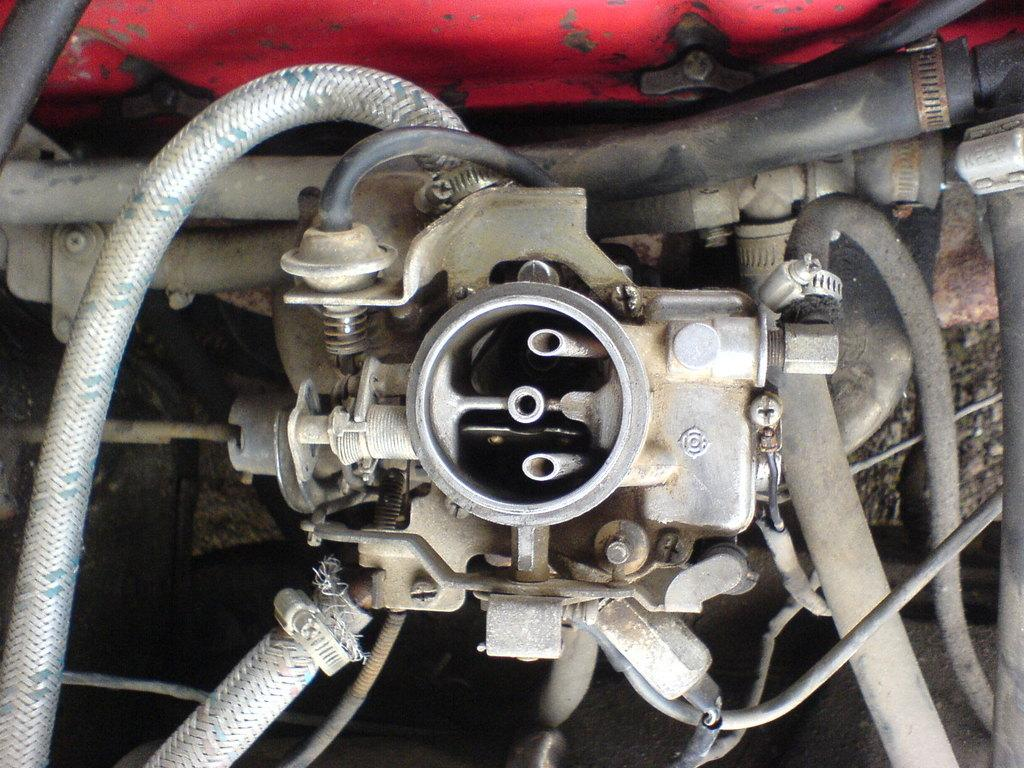What is the main subject of the image? The main subject of the image is an engine. Can you describe the location of the engine in the image? The engine is in the center of the image. What type of cast is visible on the engine in the image? There is no cast present on the engine in the image. How does the engine control the direction of the vehicle in the image? The image does not show a vehicle or any indication of the engine controlling its direction. 